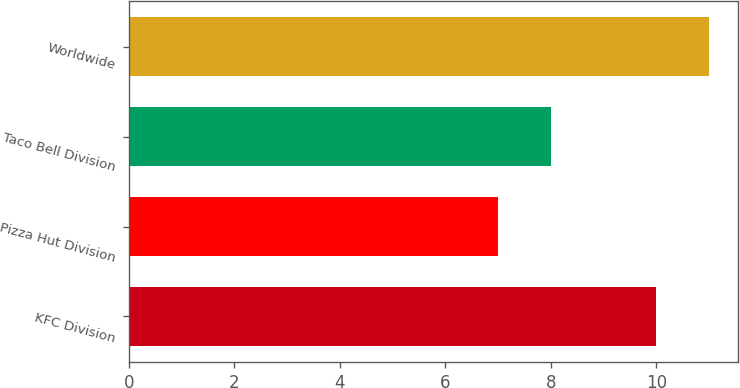Convert chart. <chart><loc_0><loc_0><loc_500><loc_500><bar_chart><fcel>KFC Division<fcel>Pizza Hut Division<fcel>Taco Bell Division<fcel>Worldwide<nl><fcel>10<fcel>7<fcel>8<fcel>11<nl></chart> 